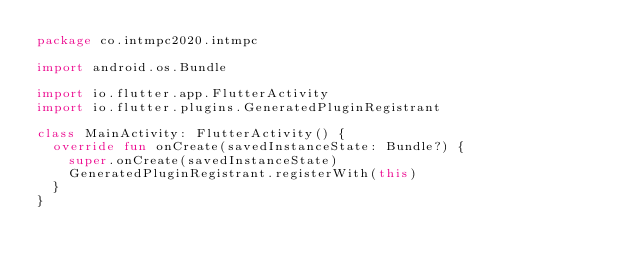<code> <loc_0><loc_0><loc_500><loc_500><_Kotlin_>package co.intmpc2020.intmpc

import android.os.Bundle

import io.flutter.app.FlutterActivity
import io.flutter.plugins.GeneratedPluginRegistrant

class MainActivity: FlutterActivity() {
  override fun onCreate(savedInstanceState: Bundle?) {
    super.onCreate(savedInstanceState)
    GeneratedPluginRegistrant.registerWith(this)
  }
}
</code> 